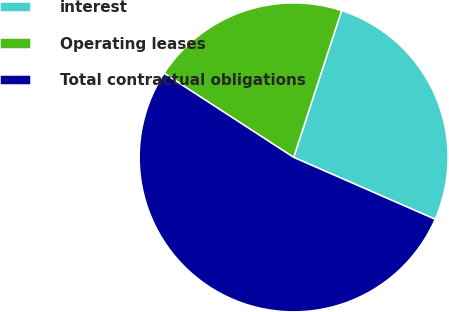Convert chart to OTSL. <chart><loc_0><loc_0><loc_500><loc_500><pie_chart><fcel>interest<fcel>Operating leases<fcel>Total contractual obligations<nl><fcel>26.54%<fcel>20.86%<fcel>52.6%<nl></chart> 